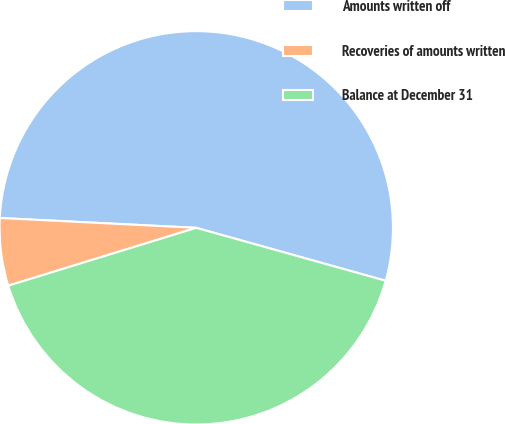Convert chart to OTSL. <chart><loc_0><loc_0><loc_500><loc_500><pie_chart><fcel>Amounts written off<fcel>Recoveries of amounts written<fcel>Balance at December 31<nl><fcel>53.54%<fcel>5.55%<fcel>40.91%<nl></chart> 